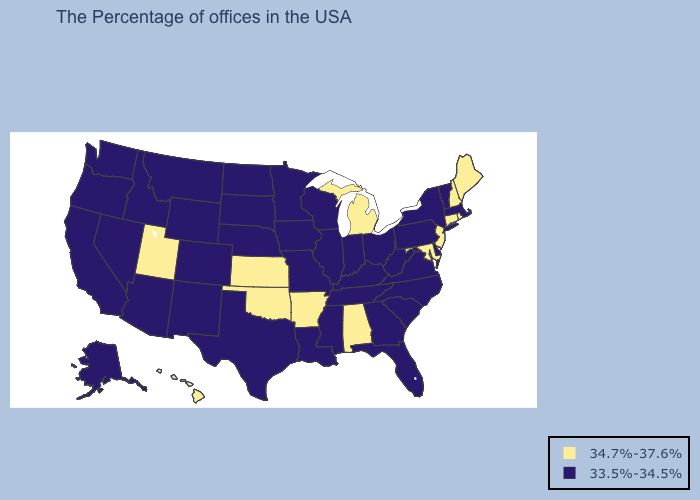What is the highest value in the MidWest ?
Write a very short answer. 34.7%-37.6%. Name the states that have a value in the range 34.7%-37.6%?
Give a very brief answer. Maine, Rhode Island, New Hampshire, Connecticut, New Jersey, Maryland, Michigan, Alabama, Arkansas, Kansas, Oklahoma, Utah, Hawaii. Does Florida have the lowest value in the South?
Give a very brief answer. Yes. Does Illinois have a lower value than Arizona?
Answer briefly. No. What is the value of California?
Concise answer only. 33.5%-34.5%. What is the lowest value in the USA?
Short answer required. 33.5%-34.5%. Which states hav the highest value in the West?
Keep it brief. Utah, Hawaii. Does Alabama have a lower value than Wisconsin?
Write a very short answer. No. What is the value of Missouri?
Quick response, please. 33.5%-34.5%. Name the states that have a value in the range 34.7%-37.6%?
Quick response, please. Maine, Rhode Island, New Hampshire, Connecticut, New Jersey, Maryland, Michigan, Alabama, Arkansas, Kansas, Oklahoma, Utah, Hawaii. Name the states that have a value in the range 33.5%-34.5%?
Write a very short answer. Massachusetts, Vermont, New York, Delaware, Pennsylvania, Virginia, North Carolina, South Carolina, West Virginia, Ohio, Florida, Georgia, Kentucky, Indiana, Tennessee, Wisconsin, Illinois, Mississippi, Louisiana, Missouri, Minnesota, Iowa, Nebraska, Texas, South Dakota, North Dakota, Wyoming, Colorado, New Mexico, Montana, Arizona, Idaho, Nevada, California, Washington, Oregon, Alaska. What is the value of Maine?
Be succinct. 34.7%-37.6%. 